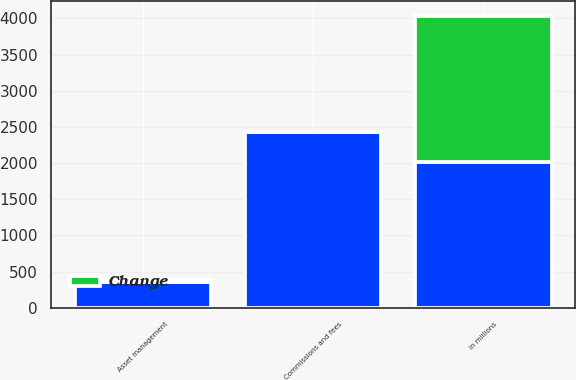<chart> <loc_0><loc_0><loc_500><loc_500><stacked_bar_chart><ecel><fcel>in millions<fcel>Commissions and fees<fcel>Asset management<nl><fcel>nan<fcel>2017<fcel>2433<fcel>359<nl><fcel>Change<fcel>2017<fcel>1<fcel>23<nl></chart> 